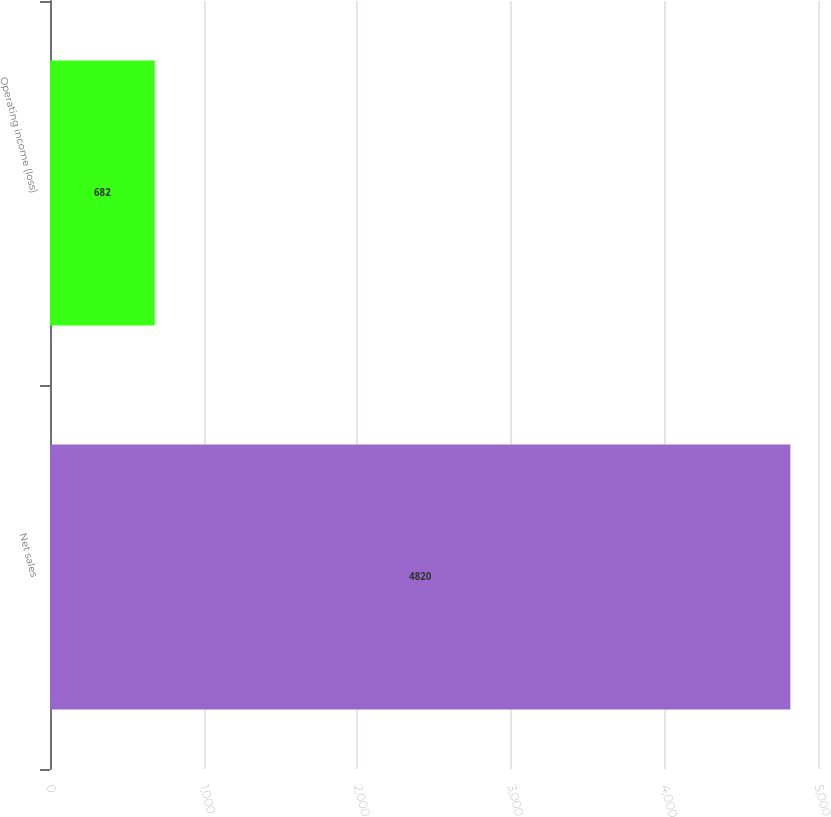<chart> <loc_0><loc_0><loc_500><loc_500><bar_chart><fcel>Net sales<fcel>Operating income (loss)<nl><fcel>4820<fcel>682<nl></chart> 